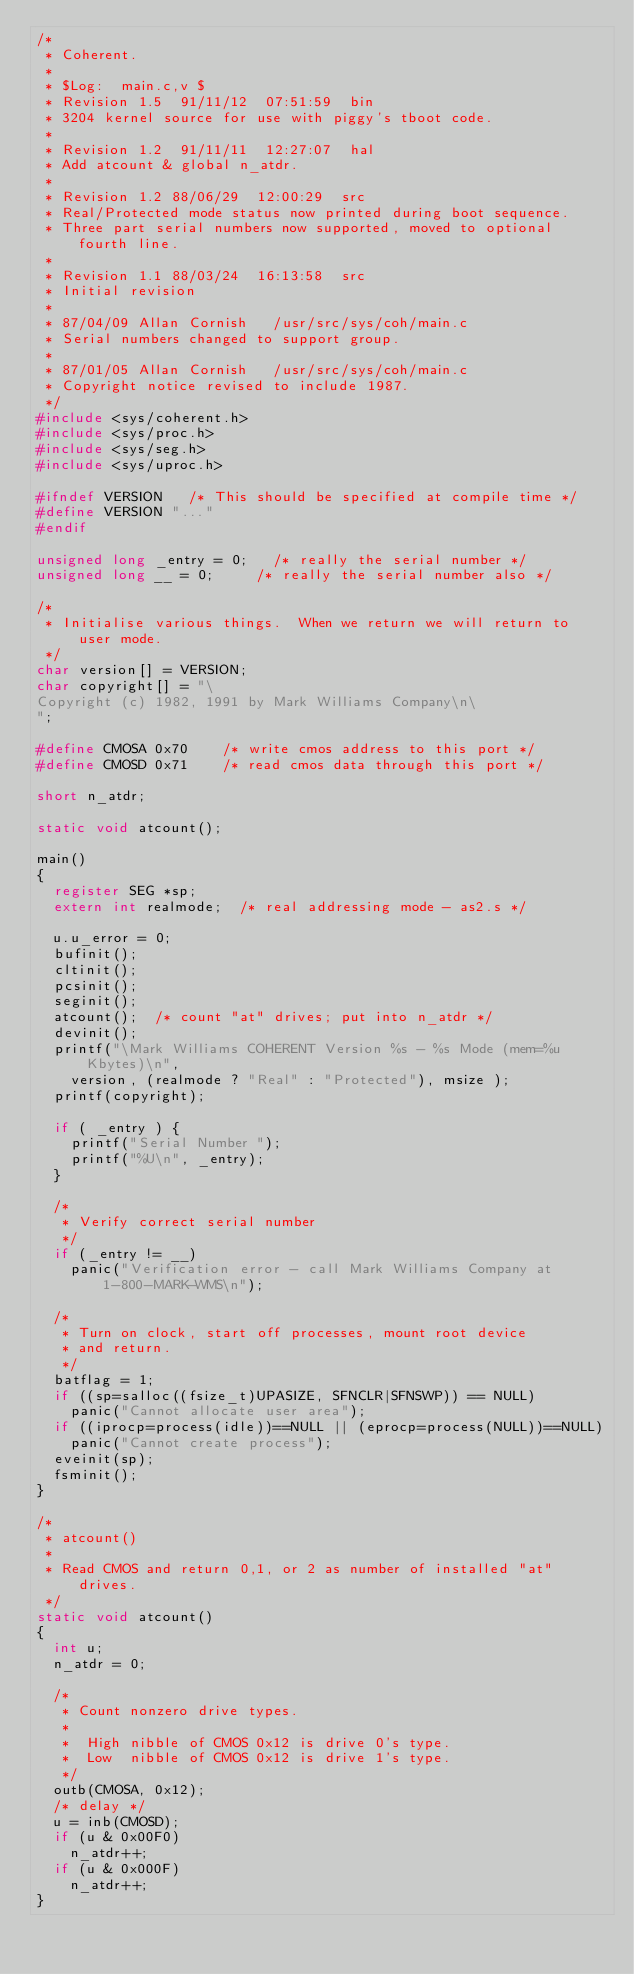Convert code to text. <code><loc_0><loc_0><loc_500><loc_500><_C_>/*
 * Coherent.
 *
 * $Log:	main.c,v $
 * Revision 1.5  91/11/12  07:51:59  bin
 * 3204 kernel source for use with piggy's tboot code.
 * 
 * Revision 1.2  91/11/11  12:27:07  hal
 * Add atcount & global n_atdr.
 * 
 * Revision 1.2	88/06/29  12:00:29 	src
 * Real/Protected mode status now printed during boot sequence.
 * Three part serial numbers now supported, moved to optional fourth line.
 * 
 * Revision 1.1	88/03/24  16:13:58	src
 * Initial revision
 * 
 * 87/04/09	Allan Cornish		/usr/src/sys/coh/main.c
 * Serial numbers changed to support group.
 *
 * 87/01/05	Allan Cornish		/usr/src/sys/coh/main.c
 * Copyright notice revised to include 1987.
 */
#include <sys/coherent.h>
#include <sys/proc.h>
#include <sys/seg.h>
#include <sys/uproc.h>

#ifndef VERSION		/* This should be specified at compile time */
#define VERSION	"..."
#endif

unsigned long	_entry = 0;		/* really the serial number */
unsigned long	__ = 0;			/* really the serial number also */

/*
 * Initialise various things.  When we return we will return to user mode.
 */
char version[] = VERSION;
char copyright[] = "\
Copyright (c) 1982, 1991 by Mark Williams Company\n\
";

#define	CMOSA	0x70		/* write cmos address to this port */
#define	CMOSD	0x71		/* read cmos data through this port */

short n_atdr;

static void atcount();

main()
{
	register SEG *sp;
	extern int realmode;	/* real addressing mode - as2.s */

	u.u_error = 0;
	bufinit();
	cltinit();
	pcsinit();
	seginit();
	atcount();	/* count "at" drives; put into n_atdr */
	devinit();
	printf("\Mark Williams COHERENT Version %s - %s Mode (mem=%u Kbytes)\n",
		version, (realmode ? "Real" : "Protected"), msize );
	printf(copyright);

	if ( _entry ) {
		printf("Serial Number ");
		printf("%U\n", _entry);
	}

	/*
	 * Verify correct serial number
	 */
	if (_entry != __)
		panic("Verification error - call Mark Williams Company at 1-800-MARK-WMS\n");

	/*
	 * Turn on clock, start off processes, mount root device
	 * and return.
	 */
	batflag = 1;
	if ((sp=salloc((fsize_t)UPASIZE, SFNCLR|SFNSWP)) == NULL)
		panic("Cannot allocate user area");
	if ((iprocp=process(idle))==NULL || (eprocp=process(NULL))==NULL)
		panic("Cannot create process");
	eveinit(sp);
	fsminit();
}

/*
 * atcount()
 *
 * Read CMOS and return 0,1, or 2 as number of installed "at" drives.
 */
static void atcount()
{
	int u;
	n_atdr = 0;

	/*
	 * Count nonzero drive types.
	 *
	 *	High nibble of CMOS 0x12 is drive 0's type.
	 *	Low  nibble of CMOS 0x12 is drive 1's type.
	 */
	outb(CMOSA, 0x12);
	/* delay */
	u = inb(CMOSD);
	if (u & 0x00F0)
		n_atdr++;
	if (u & 0x000F)
		n_atdr++;
}
</code> 